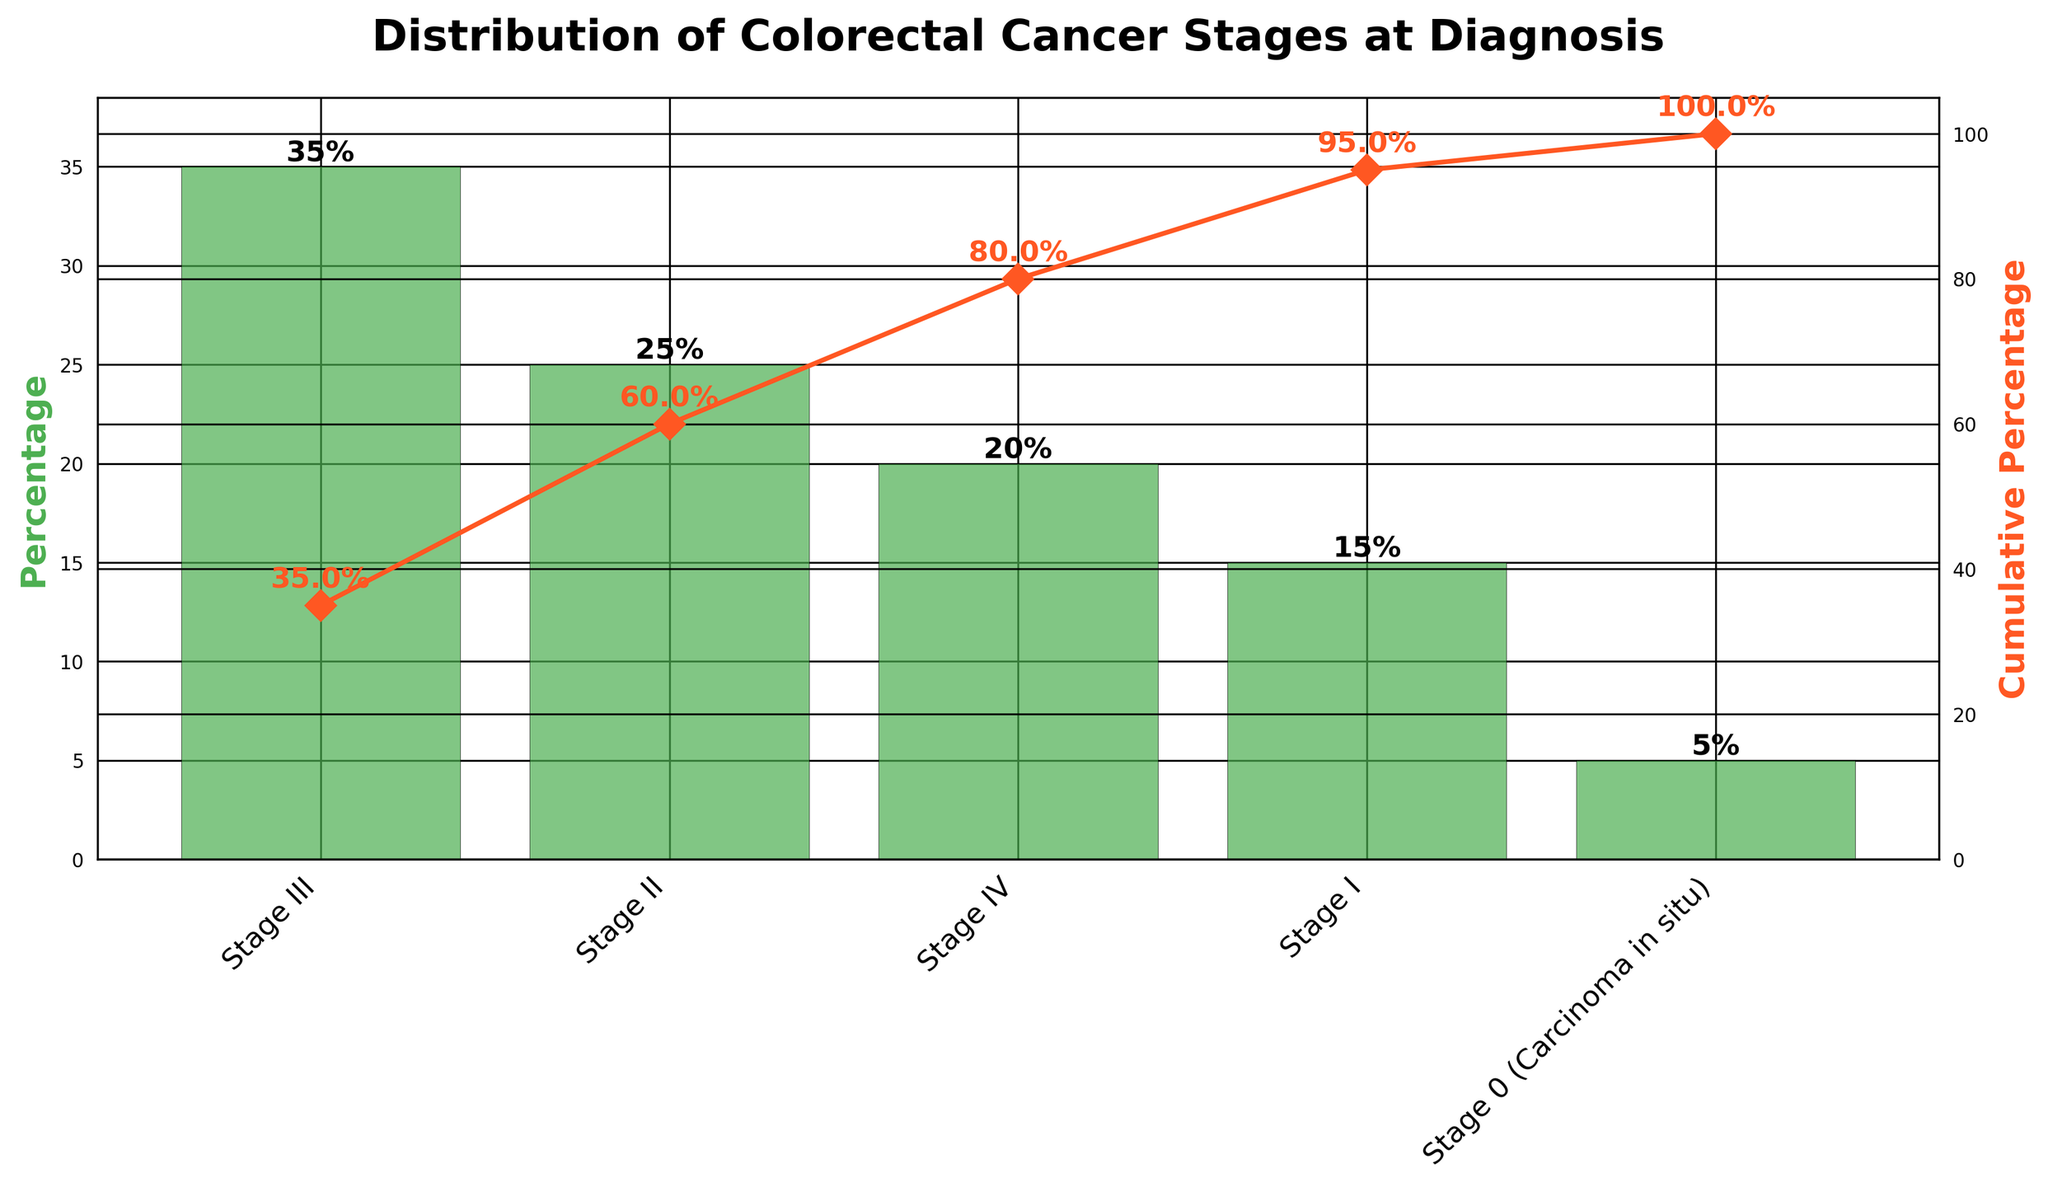What is the percentage of diagnoses in Stage III? The percentage of diagnoses in Stage III is represented by the height of the Stage III bar on the chart.
Answer: 35% What stage has the lowest percentage of diagnoses? The stage with the lowest percentage of diagnoses is indicated by the shortest bar on the chart.
Answer: Stage 0 (Carcinoma in situ) Which stages combined account for at least 50% of diagnoses? We need to sum the percentages of the stages in descending order until we reach or exceed 50%. Stage III (35%) + Stage II (25%) = 60%, which is more than 50%.
Answer: Stage III and Stage II What is the cumulative percentage of diagnoses after Stage II? The cumulative percentage after Stage II can be seen on the cumulative line chart and is annotated on the chart.
Answer: 60% How much higher is the percentage of Stage III diagnoses compared to Stage I? Subtract the percentage of Stage I from the percentage of Stage III: 35% - 15%.
Answer: 20% What is the cumulative percentage of all stages combined? The cumulative percentage of all stages is seen at the last point on the cumulative line chart.
Answer: 100% Is the cumulative percentage after Stage IV above or below 80%? The cumulative percentage after Stage IV is represented on the line graph, annotated as 80%.
Answer: Equal to 80% Which stage’s diagnoses contribute the most to the cumulative percentage reaching 80%? Identify the diagnosis stage with the largest single contribution before the cumulative percentage reaches 80%.
Answer: Stage III How many stages are there in total? The total number of stages is indicated by the number of bars on the chart.
Answer: 5 What is the total percentage of diagnoses for Stages I and IV combined? Combine the percentages of Stages I and IV: 15% + 20%.
Answer: 35% 